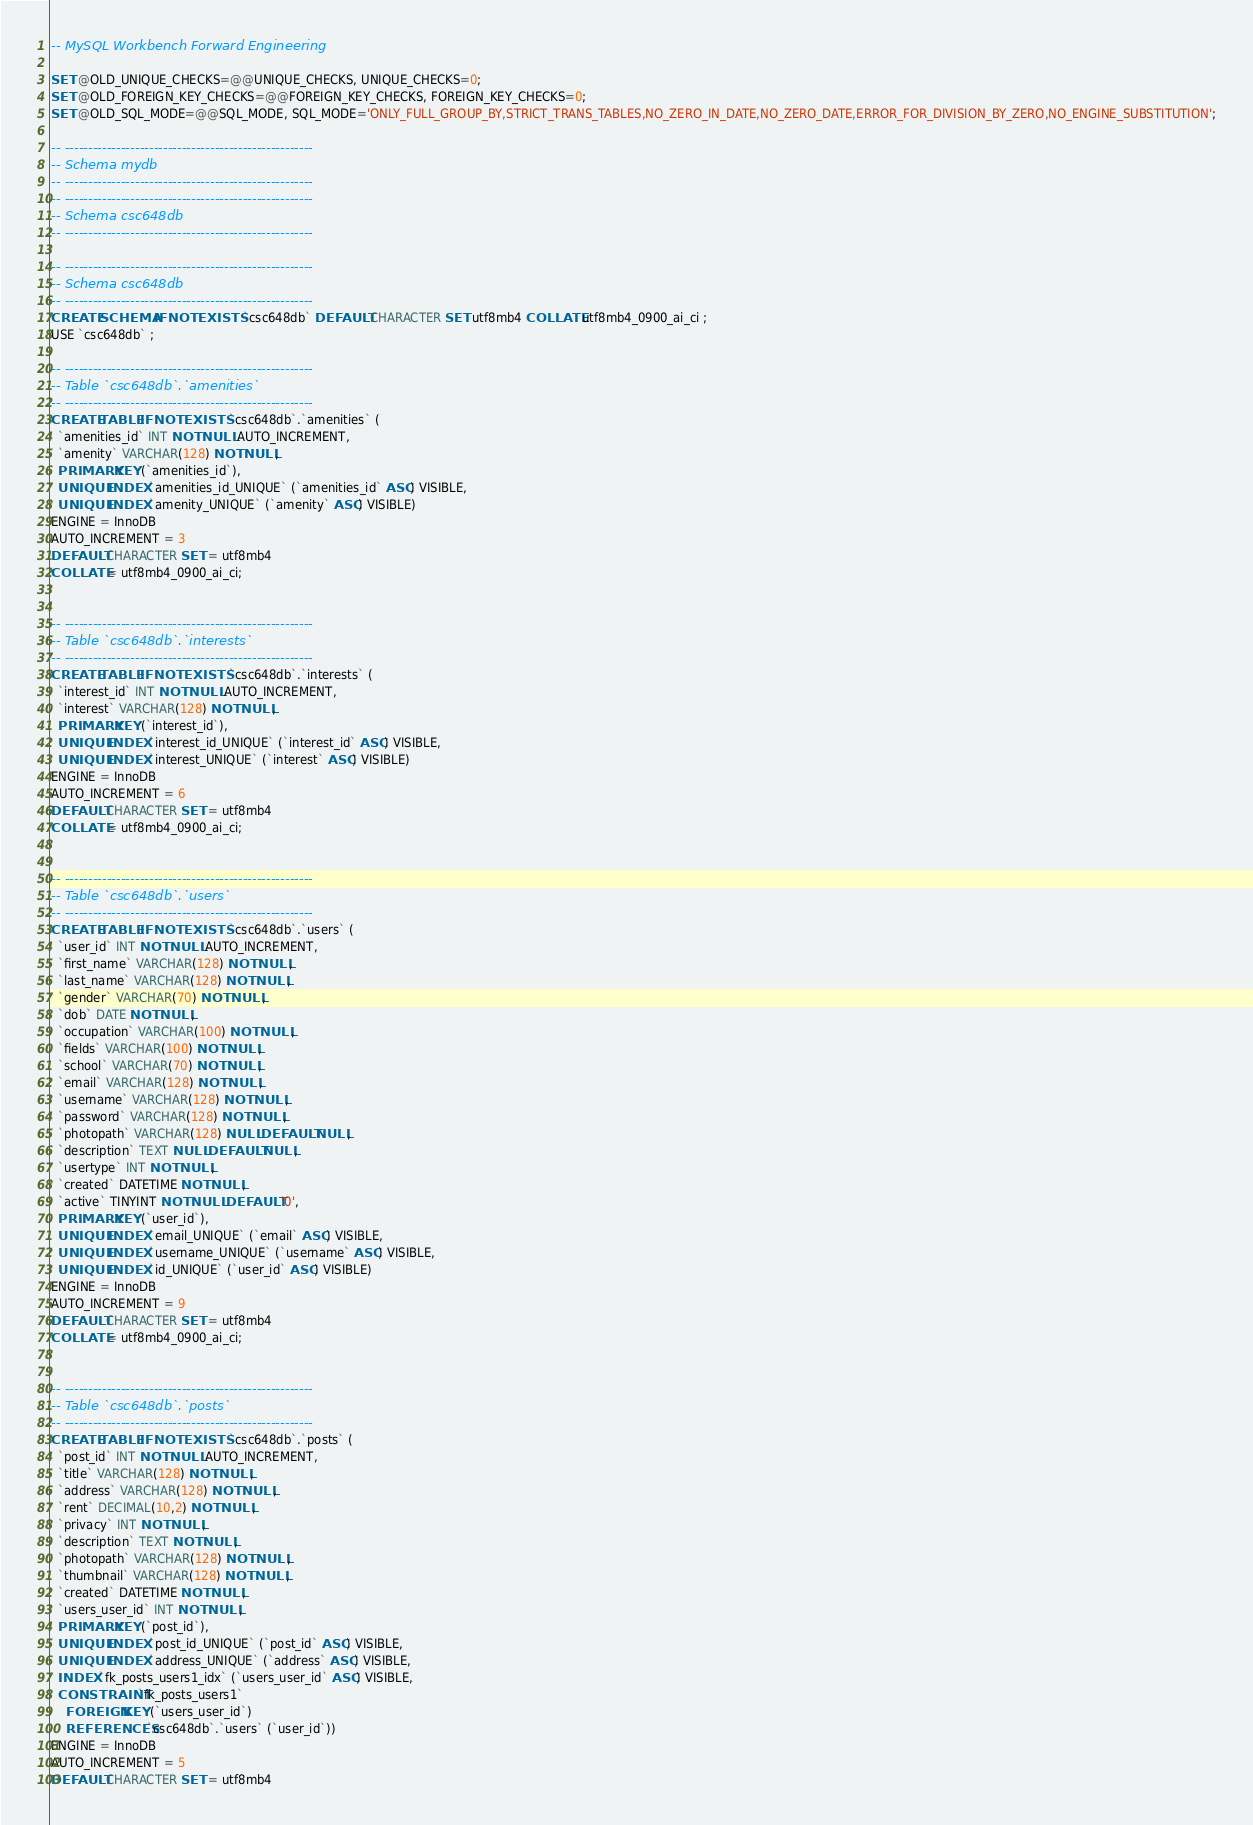<code> <loc_0><loc_0><loc_500><loc_500><_SQL_>-- MySQL Workbench Forward Engineering

SET @OLD_UNIQUE_CHECKS=@@UNIQUE_CHECKS, UNIQUE_CHECKS=0;
SET @OLD_FOREIGN_KEY_CHECKS=@@FOREIGN_KEY_CHECKS, FOREIGN_KEY_CHECKS=0;
SET @OLD_SQL_MODE=@@SQL_MODE, SQL_MODE='ONLY_FULL_GROUP_BY,STRICT_TRANS_TABLES,NO_ZERO_IN_DATE,NO_ZERO_DATE,ERROR_FOR_DIVISION_BY_ZERO,NO_ENGINE_SUBSTITUTION';

-- -----------------------------------------------------
-- Schema mydb
-- -----------------------------------------------------
-- -----------------------------------------------------
-- Schema csc648db
-- -----------------------------------------------------

-- -----------------------------------------------------
-- Schema csc648db
-- -----------------------------------------------------
CREATE SCHEMA IF NOT EXISTS `csc648db` DEFAULT CHARACTER SET utf8mb4 COLLATE utf8mb4_0900_ai_ci ;
USE `csc648db` ;

-- -----------------------------------------------------
-- Table `csc648db`.`amenities`
-- -----------------------------------------------------
CREATE TABLE IF NOT EXISTS `csc648db`.`amenities` (
  `amenities_id` INT NOT NULL AUTO_INCREMENT,
  `amenity` VARCHAR(128) NOT NULL,
  PRIMARY KEY (`amenities_id`),
  UNIQUE INDEX `amenities_id_UNIQUE` (`amenities_id` ASC) VISIBLE,
  UNIQUE INDEX `amenity_UNIQUE` (`amenity` ASC) VISIBLE)
ENGINE = InnoDB
AUTO_INCREMENT = 3
DEFAULT CHARACTER SET = utf8mb4
COLLATE = utf8mb4_0900_ai_ci;


-- -----------------------------------------------------
-- Table `csc648db`.`interests`
-- -----------------------------------------------------
CREATE TABLE IF NOT EXISTS `csc648db`.`interests` (
  `interest_id` INT NOT NULL AUTO_INCREMENT,
  `interest` VARCHAR(128) NOT NULL,
  PRIMARY KEY (`interest_id`),
  UNIQUE INDEX `interest_id_UNIQUE` (`interest_id` ASC) VISIBLE,
  UNIQUE INDEX `interest_UNIQUE` (`interest` ASC) VISIBLE)
ENGINE = InnoDB
AUTO_INCREMENT = 6
DEFAULT CHARACTER SET = utf8mb4
COLLATE = utf8mb4_0900_ai_ci;


-- -----------------------------------------------------
-- Table `csc648db`.`users`
-- -----------------------------------------------------
CREATE TABLE IF NOT EXISTS `csc648db`.`users` (
  `user_id` INT NOT NULL AUTO_INCREMENT,
  `first_name` VARCHAR(128) NOT NULL,
  `last_name` VARCHAR(128) NOT NULL,
  `gender` VARCHAR(70) NOT NULL,
  `dob` DATE NOT NULL,
  `occupation` VARCHAR(100) NOT NULL,
  `fields` VARCHAR(100) NOT NULL,
  `school` VARCHAR(70) NOT NULL,
  `email` VARCHAR(128) NOT NULL,
  `username` VARCHAR(128) NOT NULL,
  `password` VARCHAR(128) NOT NULL,
  `photopath` VARCHAR(128) NULL DEFAULT NULL,
  `description` TEXT NULL DEFAULT NULL,
  `usertype` INT NOT NULL,
  `created` DATETIME NOT NULL,
  `active` TINYINT NOT NULL DEFAULT '0',
  PRIMARY KEY (`user_id`),
  UNIQUE INDEX `email_UNIQUE` (`email` ASC) VISIBLE,
  UNIQUE INDEX `username_UNIQUE` (`username` ASC) VISIBLE,
  UNIQUE INDEX `id_UNIQUE` (`user_id` ASC) VISIBLE)
ENGINE = InnoDB
AUTO_INCREMENT = 9
DEFAULT CHARACTER SET = utf8mb4
COLLATE = utf8mb4_0900_ai_ci;


-- -----------------------------------------------------
-- Table `csc648db`.`posts`
-- -----------------------------------------------------
CREATE TABLE IF NOT EXISTS `csc648db`.`posts` (
  `post_id` INT NOT NULL AUTO_INCREMENT,
  `title` VARCHAR(128) NOT NULL,
  `address` VARCHAR(128) NOT NULL,
  `rent` DECIMAL(10,2) NOT NULL,
  `privacy` INT NOT NULL,
  `description` TEXT NOT NULL,
  `photopath` VARCHAR(128) NOT NULL,
  `thumbnail` VARCHAR(128) NOT NULL,
  `created` DATETIME NOT NULL,
  `users_user_id` INT NOT NULL,
  PRIMARY KEY (`post_id`),
  UNIQUE INDEX `post_id_UNIQUE` (`post_id` ASC) VISIBLE,
  UNIQUE INDEX `address_UNIQUE` (`address` ASC) VISIBLE,
  INDEX `fk_posts_users1_idx` (`users_user_id` ASC) VISIBLE,
  CONSTRAINT `fk_posts_users1`
    FOREIGN KEY (`users_user_id`)
    REFERENCES `csc648db`.`users` (`user_id`))
ENGINE = InnoDB
AUTO_INCREMENT = 5
DEFAULT CHARACTER SET = utf8mb4</code> 